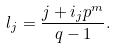<formula> <loc_0><loc_0><loc_500><loc_500>l _ { j } = \frac { j + i _ { j } p ^ { m } } { q - 1 } .</formula> 